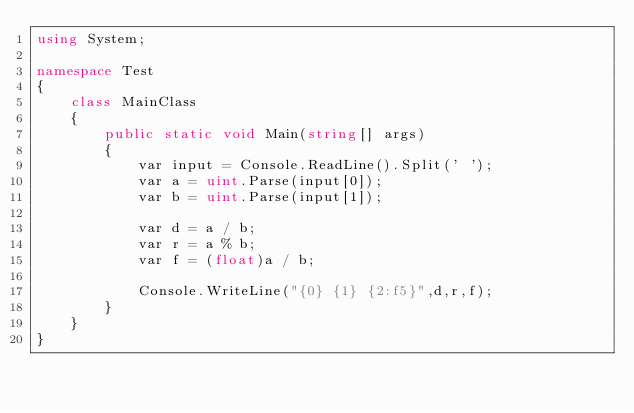<code> <loc_0><loc_0><loc_500><loc_500><_C#_>using System;

namespace Test
{
    class MainClass
    {
        public static void Main(string[] args)
        {      
            var input = Console.ReadLine().Split(' ');
            var a = uint.Parse(input[0]);
            var b = uint.Parse(input[1]);

            var d = a / b;
            var r = a % b;
            var f = (float)a / b;

            Console.WriteLine("{0} {1} {2:f5}",d,r,f);
        }
    }
}</code> 